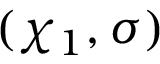Convert formula to latex. <formula><loc_0><loc_0><loc_500><loc_500>( \chi _ { 1 } , \sigma )</formula> 